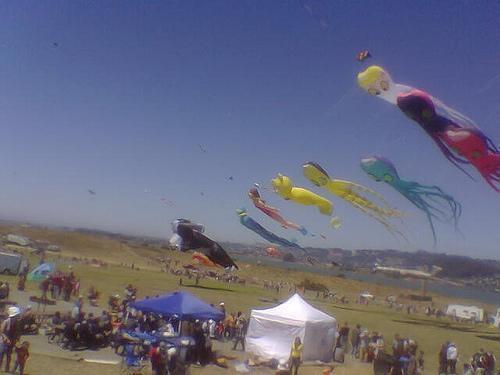What type of structures are shown?
Choose the right answer from the provided options to respond to the question.
Options: Home, tent, hotel, garage. Tent. 